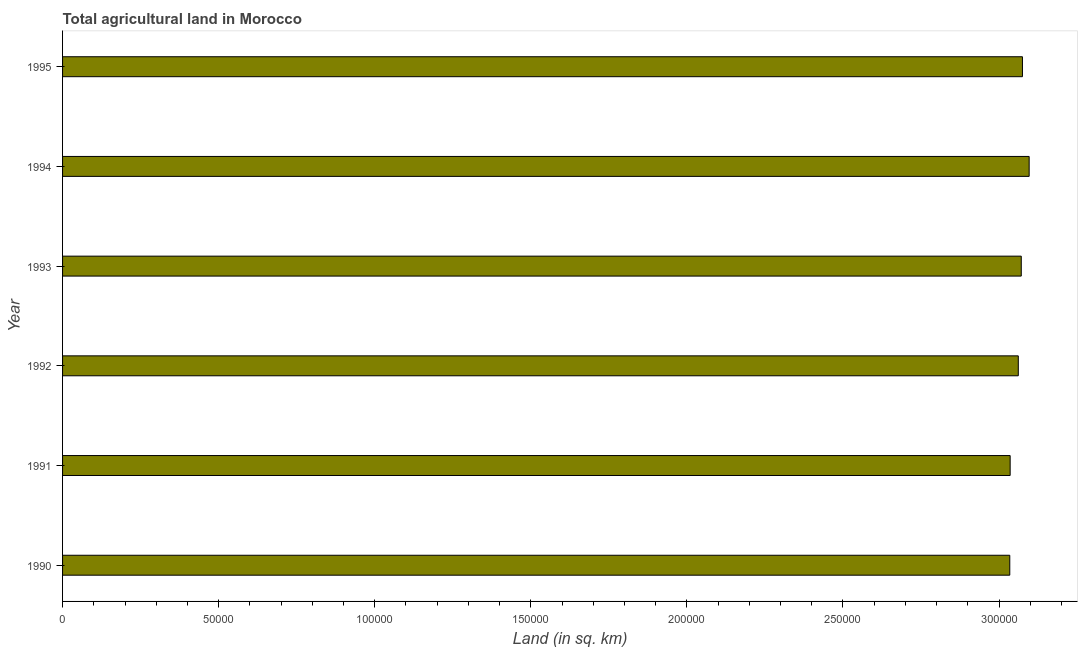Does the graph contain any zero values?
Offer a terse response. No. Does the graph contain grids?
Your answer should be very brief. No. What is the title of the graph?
Ensure brevity in your answer.  Total agricultural land in Morocco. What is the label or title of the X-axis?
Provide a succinct answer. Land (in sq. km). What is the label or title of the Y-axis?
Make the answer very short. Year. What is the agricultural land in 1992?
Provide a succinct answer. 3.06e+05. Across all years, what is the maximum agricultural land?
Your answer should be compact. 3.10e+05. Across all years, what is the minimum agricultural land?
Provide a succinct answer. 3.03e+05. In which year was the agricultural land maximum?
Ensure brevity in your answer.  1994. What is the sum of the agricultural land?
Make the answer very short. 1.84e+06. What is the difference between the agricultural land in 1990 and 1993?
Make the answer very short. -3680. What is the average agricultural land per year?
Offer a very short reply. 3.06e+05. What is the median agricultural land?
Your answer should be compact. 3.07e+05. In how many years, is the agricultural land greater than 240000 sq. km?
Offer a terse response. 6. What is the difference between the highest and the second highest agricultural land?
Provide a short and direct response. 2150. Is the sum of the agricultural land in 1990 and 1992 greater than the maximum agricultural land across all years?
Provide a short and direct response. Yes. What is the difference between the highest and the lowest agricultural land?
Your answer should be compact. 6210. How many years are there in the graph?
Give a very brief answer. 6. What is the difference between two consecutive major ticks on the X-axis?
Keep it short and to the point. 5.00e+04. Are the values on the major ticks of X-axis written in scientific E-notation?
Offer a terse response. No. What is the Land (in sq. km) of 1990?
Your response must be concise. 3.03e+05. What is the Land (in sq. km) in 1991?
Ensure brevity in your answer.  3.04e+05. What is the Land (in sq. km) of 1992?
Ensure brevity in your answer.  3.06e+05. What is the Land (in sq. km) in 1993?
Ensure brevity in your answer.  3.07e+05. What is the Land (in sq. km) in 1994?
Provide a succinct answer. 3.10e+05. What is the Land (in sq. km) in 1995?
Your response must be concise. 3.07e+05. What is the difference between the Land (in sq. km) in 1990 and 1991?
Ensure brevity in your answer.  -120. What is the difference between the Land (in sq. km) in 1990 and 1992?
Offer a very short reply. -2730. What is the difference between the Land (in sq. km) in 1990 and 1993?
Your answer should be compact. -3680. What is the difference between the Land (in sq. km) in 1990 and 1994?
Provide a short and direct response. -6210. What is the difference between the Land (in sq. km) in 1990 and 1995?
Your response must be concise. -4060. What is the difference between the Land (in sq. km) in 1991 and 1992?
Make the answer very short. -2610. What is the difference between the Land (in sq. km) in 1991 and 1993?
Ensure brevity in your answer.  -3560. What is the difference between the Land (in sq. km) in 1991 and 1994?
Provide a short and direct response. -6090. What is the difference between the Land (in sq. km) in 1991 and 1995?
Offer a terse response. -3940. What is the difference between the Land (in sq. km) in 1992 and 1993?
Ensure brevity in your answer.  -950. What is the difference between the Land (in sq. km) in 1992 and 1994?
Your answer should be compact. -3480. What is the difference between the Land (in sq. km) in 1992 and 1995?
Make the answer very short. -1330. What is the difference between the Land (in sq. km) in 1993 and 1994?
Offer a very short reply. -2530. What is the difference between the Land (in sq. km) in 1993 and 1995?
Keep it short and to the point. -380. What is the difference between the Land (in sq. km) in 1994 and 1995?
Provide a short and direct response. 2150. What is the ratio of the Land (in sq. km) in 1990 to that in 1994?
Your answer should be compact. 0.98. What is the ratio of the Land (in sq. km) in 1990 to that in 1995?
Offer a very short reply. 0.99. What is the ratio of the Land (in sq. km) in 1991 to that in 1992?
Your answer should be compact. 0.99. What is the ratio of the Land (in sq. km) in 1991 to that in 1993?
Provide a short and direct response. 0.99. What is the ratio of the Land (in sq. km) in 1992 to that in 1993?
Provide a succinct answer. 1. What is the ratio of the Land (in sq. km) in 1992 to that in 1994?
Keep it short and to the point. 0.99. What is the ratio of the Land (in sq. km) in 1992 to that in 1995?
Keep it short and to the point. 1. 